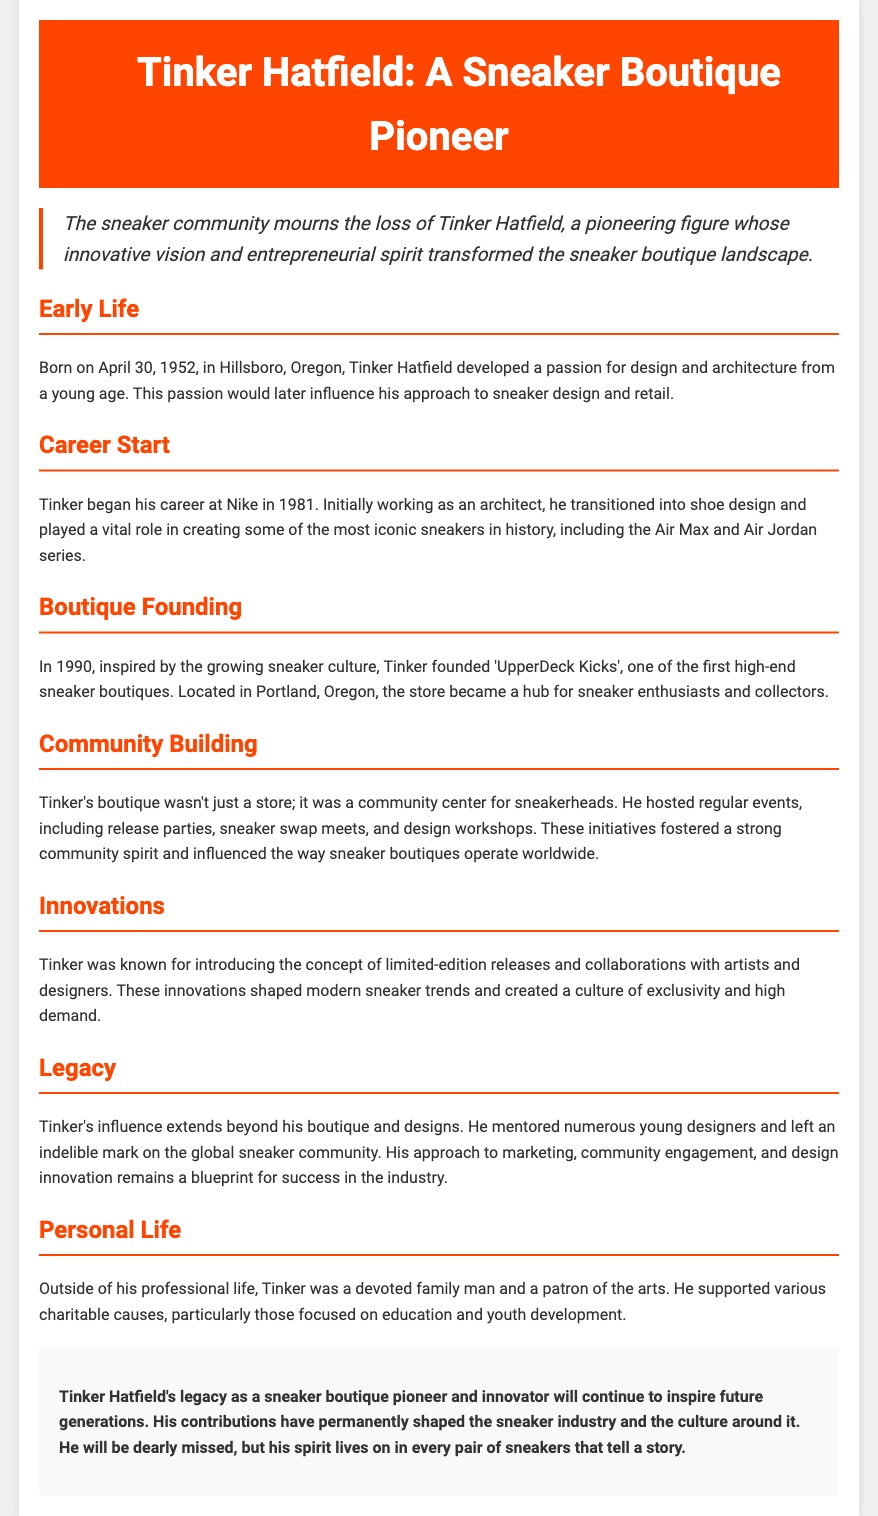what date was Tinker Hatfield born? The document states Tinker Hatfield was born on April 30, 1952.
Answer: April 30, 1952 what was Tinker Hatfield's initial profession at Nike? Tinker Hatfield started his career at Nike as an architect before transitioning to shoe design.
Answer: architect what is the name of the boutique Tinker founded? The document mentions that Tinker founded 'UpperDeck Kicks'.
Answer: UpperDeck Kicks in what year was 'UpperDeck Kicks' established? According to the document, Tinker founded the boutique in 1990.
Answer: 1990 what was one innovative concept introduced by Tinker Hatfield? The document highlights that Tinker was known for introducing limited-edition releases.
Answer: limited-edition releases how did Tinker contribute to the community? Tinker hosted events like release parties and sneaker swap meets, fostering community spirit.
Answer: community events what phrase describes Tinker's influence on young designers? The document states that Tinker mentored numerous young designers.
Answer: mentored young designers what type of causes did Tinker support? Tinker was a patron of charitable causes focused on education and youth development.
Answer: education and youth development what is Tinker Hatfield considered in the sneaker industry? The document describes Tinker as a pioneer in the sneaker boutique landscape.
Answer: pioneer 